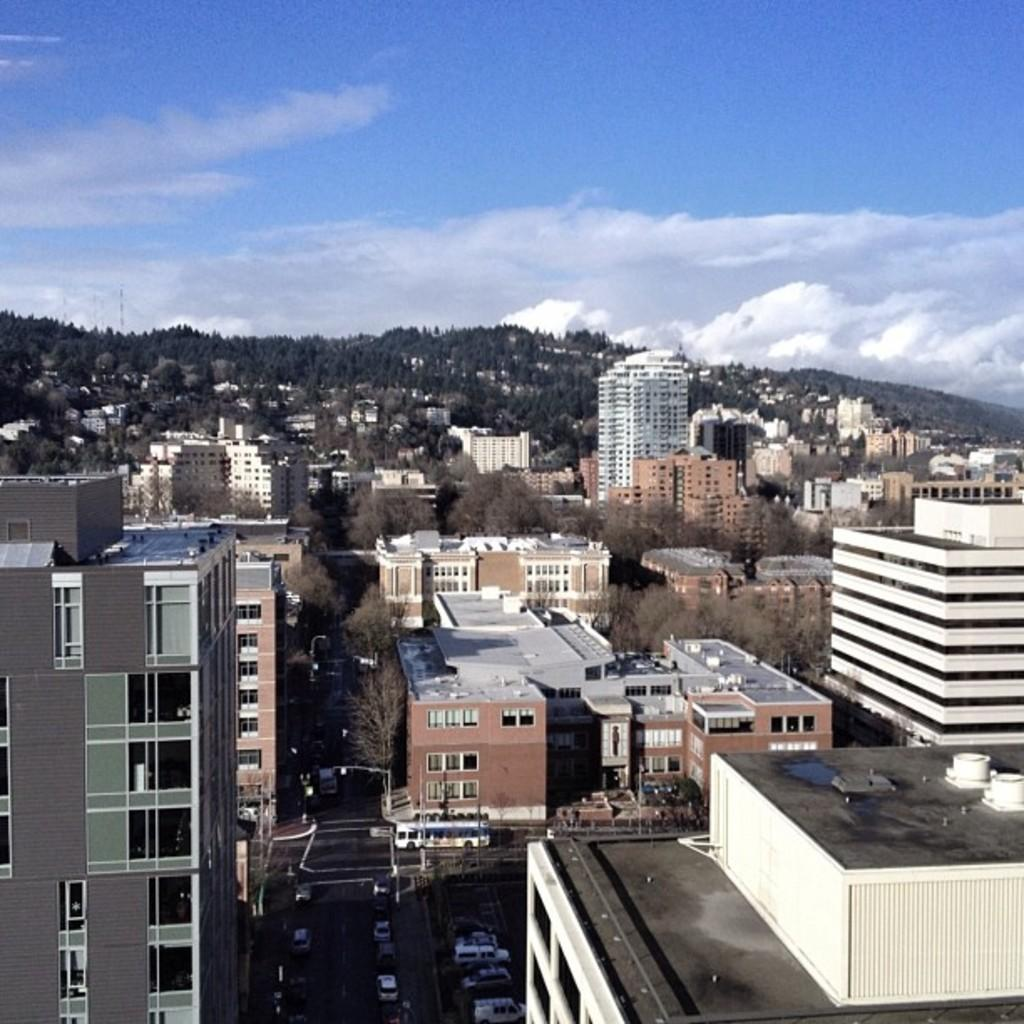What type of structures can be seen in the image? There are buildings in the image. What other natural elements are present in the image? There are trees in the image. What is happening on the road in the image? There are vehicles on the road in the image. What geographical feature is located in the middle of the image? There is a hill in the middle of the image. What is visible at the top of the image? The sky is visible at the top of the image. What process is being used to determine the value of the board in the image? There is no board present in the image, and therefore no such process or value can be observed. 